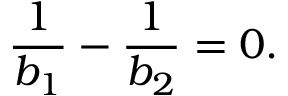Convert formula to latex. <formula><loc_0><loc_0><loc_500><loc_500>\frac { 1 } { b _ { 1 } } - \frac { 1 } { b _ { 2 } } = 0 .</formula> 